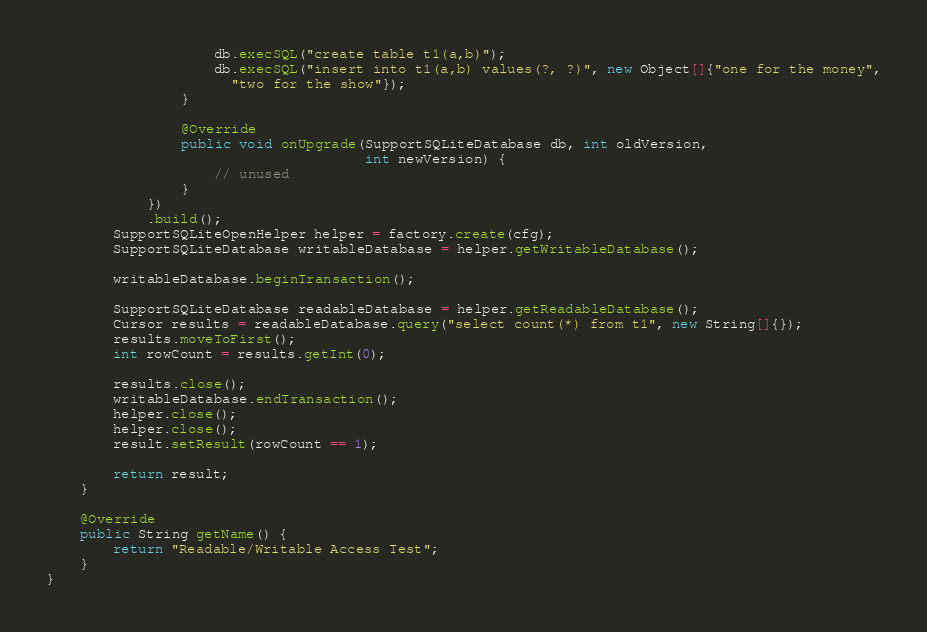<code> <loc_0><loc_0><loc_500><loc_500><_Java_>                    db.execSQL("create table t1(a,b)");
                    db.execSQL("insert into t1(a,b) values(?, ?)", new Object[]{"one for the money",
                      "two for the show"});
                }

                @Override
                public void onUpgrade(SupportSQLiteDatabase db, int oldVersion,
                                      int newVersion) {
                    // unused
                }
            })
            .build();
        SupportSQLiteOpenHelper helper = factory.create(cfg);
        SupportSQLiteDatabase writableDatabase = helper.getWritableDatabase();

        writableDatabase.beginTransaction();

        SupportSQLiteDatabase readableDatabase = helper.getReadableDatabase();
        Cursor results = readableDatabase.query("select count(*) from t1", new String[]{});
        results.moveToFirst();
        int rowCount = results.getInt(0);

        results.close();
        writableDatabase.endTransaction();
        helper.close();
        helper.close();
        result.setResult(rowCount == 1);

        return result;
    }

    @Override
    public String getName() {
        return "Readable/Writable Access Test";
    }
}
</code> 